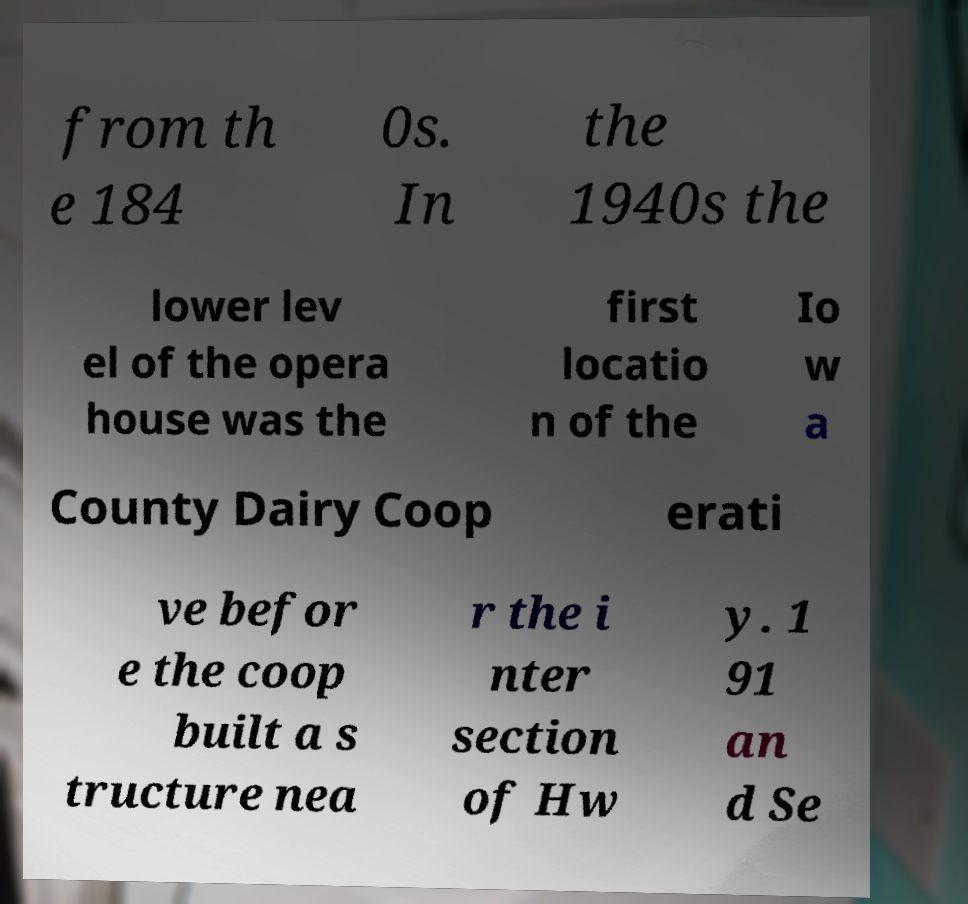Could you assist in decoding the text presented in this image and type it out clearly? from th e 184 0s. In the 1940s the lower lev el of the opera house was the first locatio n of the Io w a County Dairy Coop erati ve befor e the coop built a s tructure nea r the i nter section of Hw y. 1 91 an d Se 